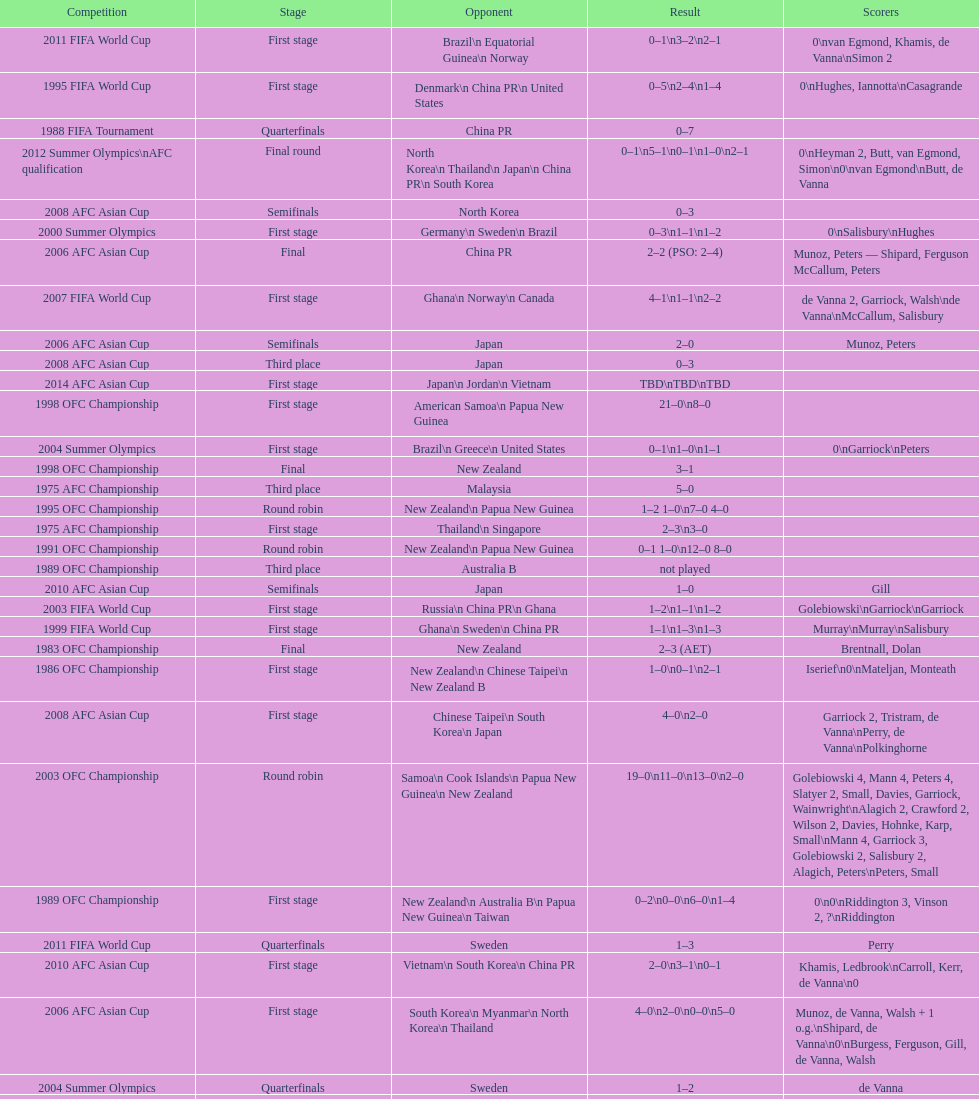What is the difference in the number of goals scored in the 1999 fifa world cup and the 2000 summer olympics? 2. 